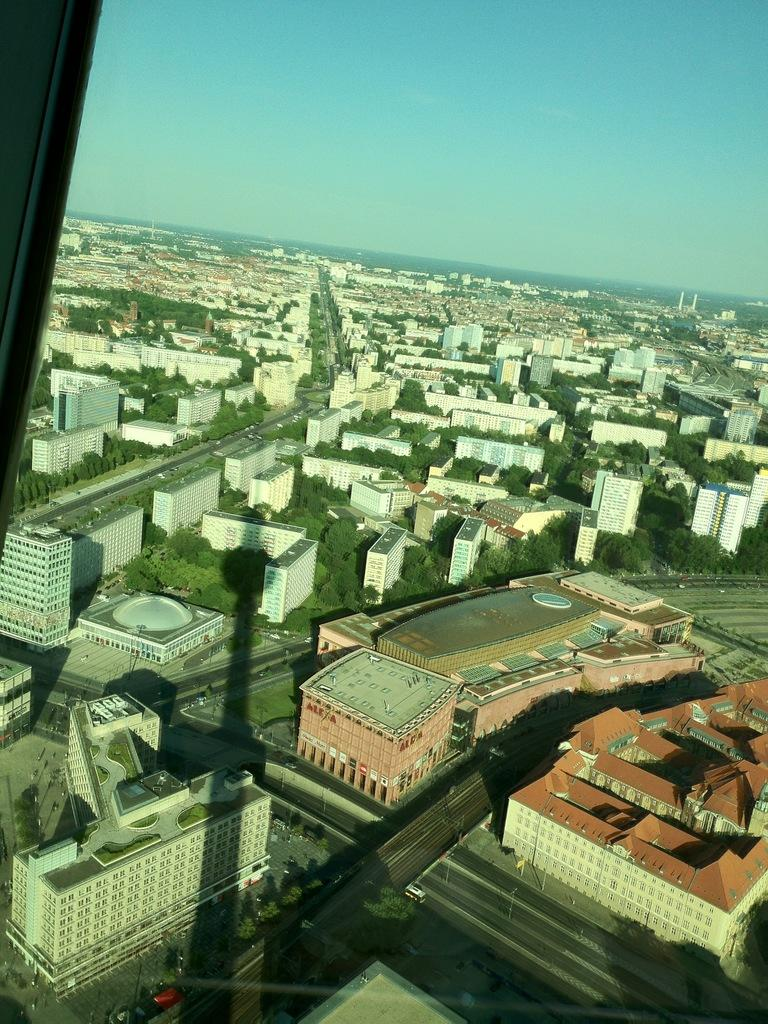What type of structures can be seen in the image? There are buildings in the image. What other natural elements are present in the image? There are trees in the image. Are there any man-made features besides the buildings? Yes, there are roads in the image. What can be seen in the background of the image? The sky is visible in the background of the image. What type of pain is the goose experiencing in the image? There is no goose present in the image, so it is not possible to determine if any pain is being experienced. 